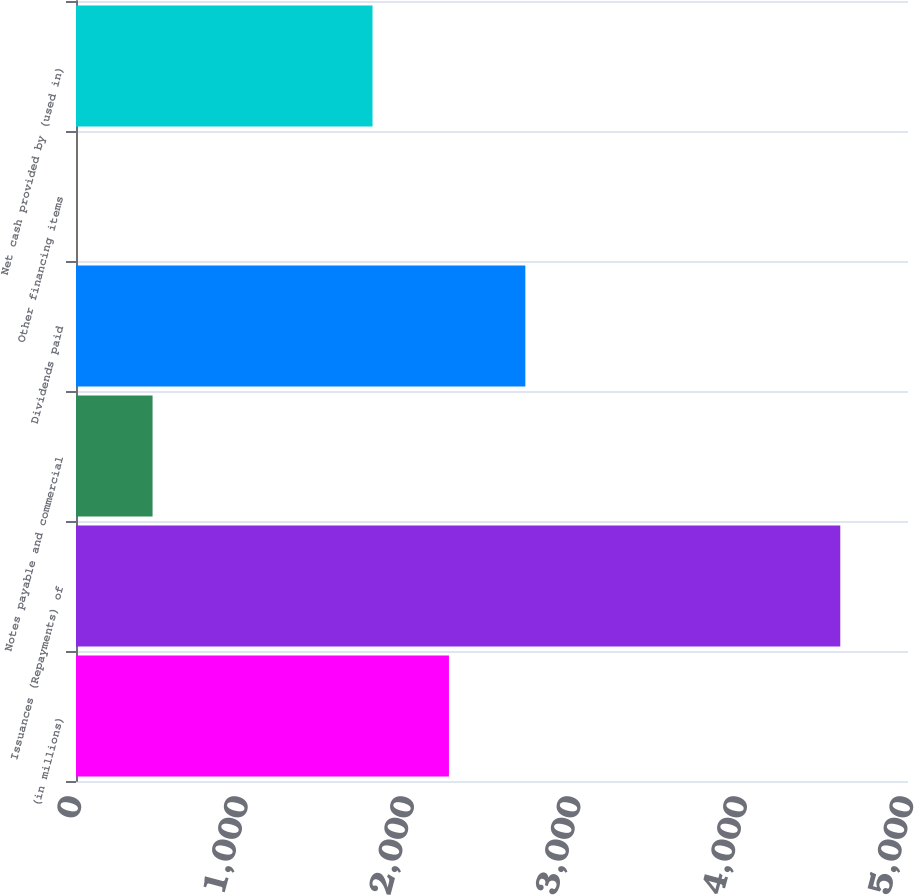Convert chart. <chart><loc_0><loc_0><loc_500><loc_500><bar_chart><fcel>(in millions)<fcel>Issuances (Repayments) of<fcel>Notes payable and commercial<fcel>Dividends paid<fcel>Other financing items<fcel>Net cash provided by (used in)<nl><fcel>2241.2<fcel>4593<fcel>460.2<fcel>2700.4<fcel>1<fcel>1782<nl></chart> 